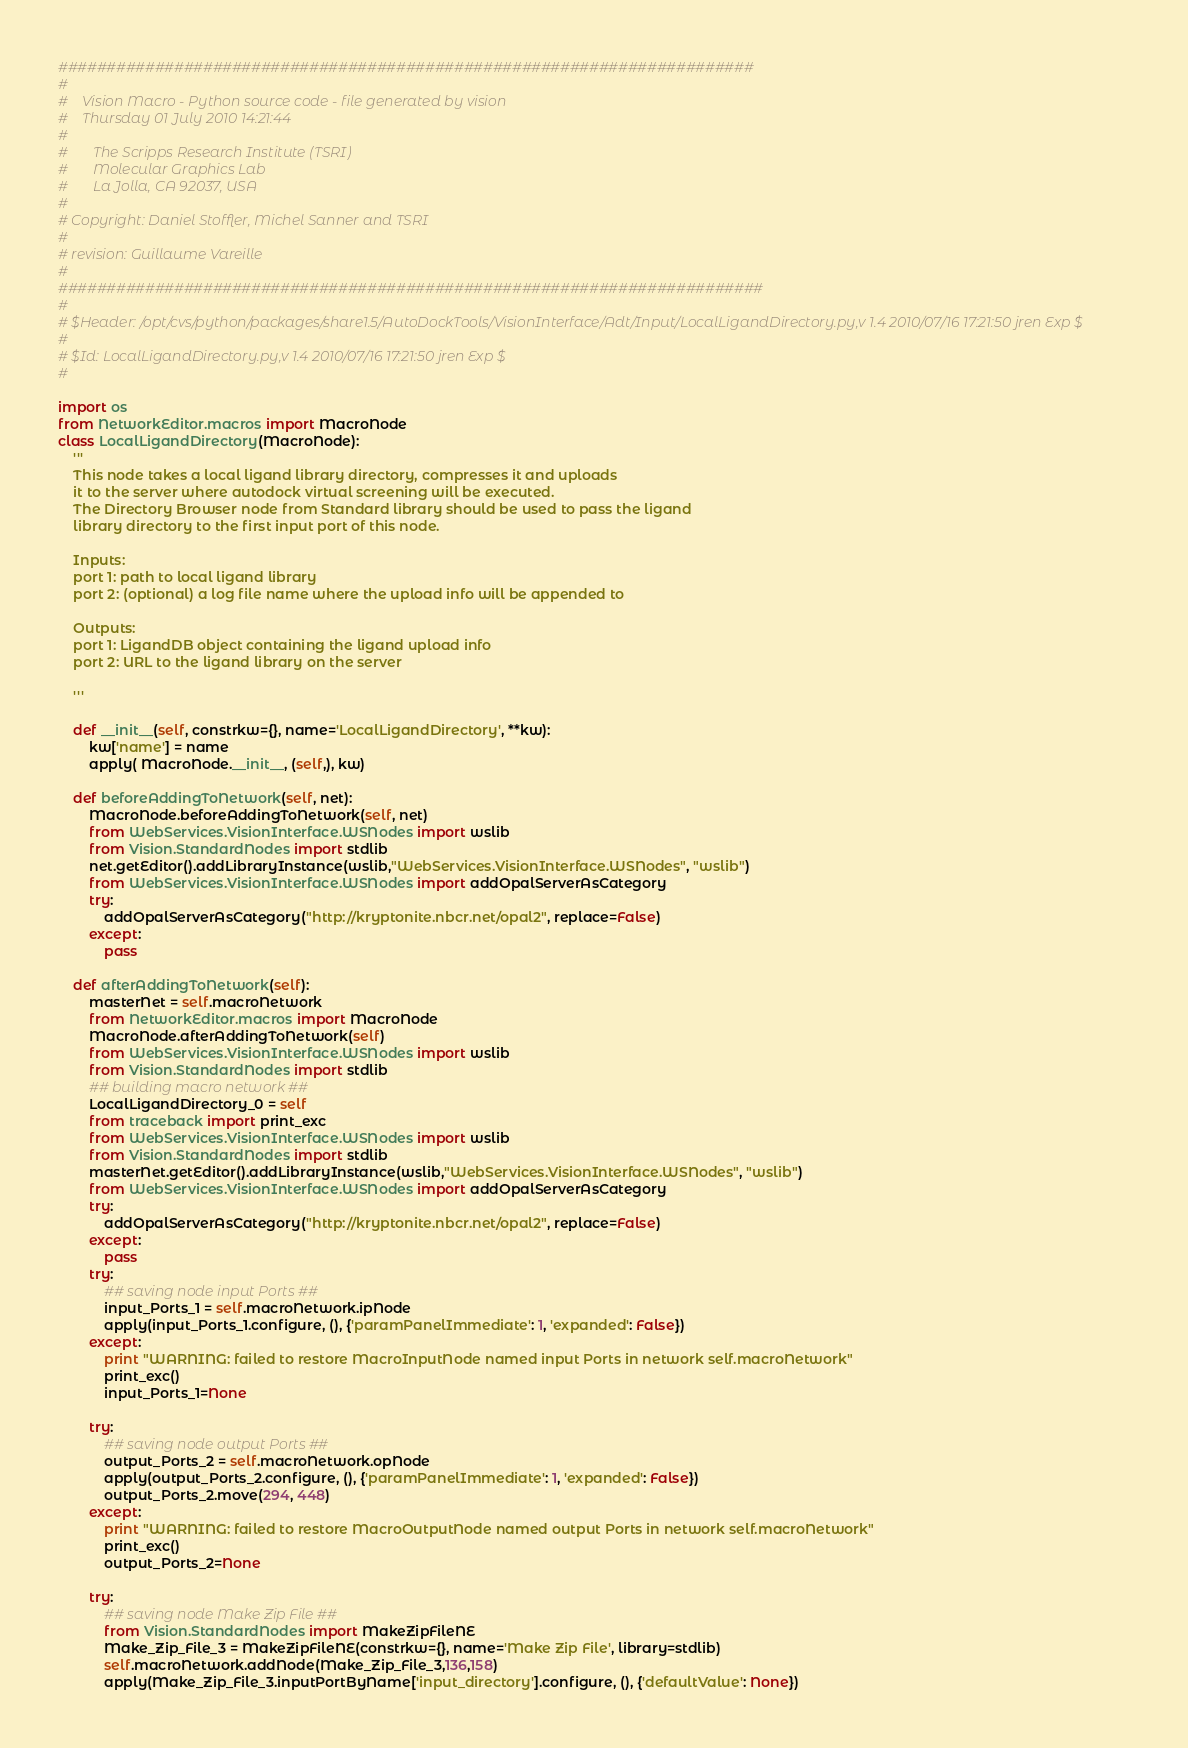<code> <loc_0><loc_0><loc_500><loc_500><_Python_>########################################################################
#
#    Vision Macro - Python source code - file generated by vision
#    Thursday 01 July 2010 14:21:44 
#    
#       The Scripps Research Institute (TSRI)
#       Molecular Graphics Lab
#       La Jolla, CA 92037, USA
#
# Copyright: Daniel Stoffler, Michel Sanner and TSRI
#   
# revision: Guillaume Vareille
#  
#########################################################################
#
# $Header: /opt/cvs/python/packages/share1.5/AutoDockTools/VisionInterface/Adt/Input/LocalLigandDirectory.py,v 1.4 2010/07/16 17:21:50 jren Exp $
#
# $Id: LocalLigandDirectory.py,v 1.4 2010/07/16 17:21:50 jren Exp $
#

import os
from NetworkEditor.macros import MacroNode
class LocalLigandDirectory(MacroNode):
    ''' 
    This node takes a local ligand library directory, compresses it and uploads
    it to the server where autodock virtual screening will be executed.  
    The Directory Browser node from Standard library should be used to pass the ligand
    library directory to the first input port of this node.

    Inputs:
    port 1: path to local ligand library 
    port 2: (optional) a log file name where the upload info will be appended to

    Outputs:
    port 1: LigandDB object containing the ligand upload info
    port 2: URL to the ligand library on the server
   
    '''

    def __init__(self, constrkw={}, name='LocalLigandDirectory', **kw):
        kw['name'] = name
        apply( MacroNode.__init__, (self,), kw)

    def beforeAddingToNetwork(self, net):
        MacroNode.beforeAddingToNetwork(self, net)
        from WebServices.VisionInterface.WSNodes import wslib
        from Vision.StandardNodes import stdlib
        net.getEditor().addLibraryInstance(wslib,"WebServices.VisionInterface.WSNodes", "wslib")
        from WebServices.VisionInterface.WSNodes import addOpalServerAsCategory
        try:
            addOpalServerAsCategory("http://kryptonite.nbcr.net/opal2", replace=False)
        except:
            pass

    def afterAddingToNetwork(self):
        masterNet = self.macroNetwork
        from NetworkEditor.macros import MacroNode
        MacroNode.afterAddingToNetwork(self)
        from WebServices.VisionInterface.WSNodes import wslib
        from Vision.StandardNodes import stdlib
        ## building macro network ##
        LocalLigandDirectory_0 = self
        from traceback import print_exc
        from WebServices.VisionInterface.WSNodes import wslib
        from Vision.StandardNodes import stdlib
        masterNet.getEditor().addLibraryInstance(wslib,"WebServices.VisionInterface.WSNodes", "wslib")
        from WebServices.VisionInterface.WSNodes import addOpalServerAsCategory
        try:
            addOpalServerAsCategory("http://kryptonite.nbcr.net/opal2", replace=False)
        except:
            pass
        try:
            ## saving node input Ports ##
            input_Ports_1 = self.macroNetwork.ipNode
            apply(input_Ports_1.configure, (), {'paramPanelImmediate': 1, 'expanded': False})
        except:
            print "WARNING: failed to restore MacroInputNode named input Ports in network self.macroNetwork"
            print_exc()
            input_Ports_1=None

        try:
            ## saving node output Ports ##
            output_Ports_2 = self.macroNetwork.opNode
            apply(output_Ports_2.configure, (), {'paramPanelImmediate': 1, 'expanded': False})
            output_Ports_2.move(294, 448)
        except:
            print "WARNING: failed to restore MacroOutputNode named output Ports in network self.macroNetwork"
            print_exc()
            output_Ports_2=None

        try:
            ## saving node Make Zip File ##
            from Vision.StandardNodes import MakeZipFileNE
            Make_Zip_File_3 = MakeZipFileNE(constrkw={}, name='Make Zip File', library=stdlib)
            self.macroNetwork.addNode(Make_Zip_File_3,136,158)
            apply(Make_Zip_File_3.inputPortByName['input_directory'].configure, (), {'defaultValue': None})</code> 